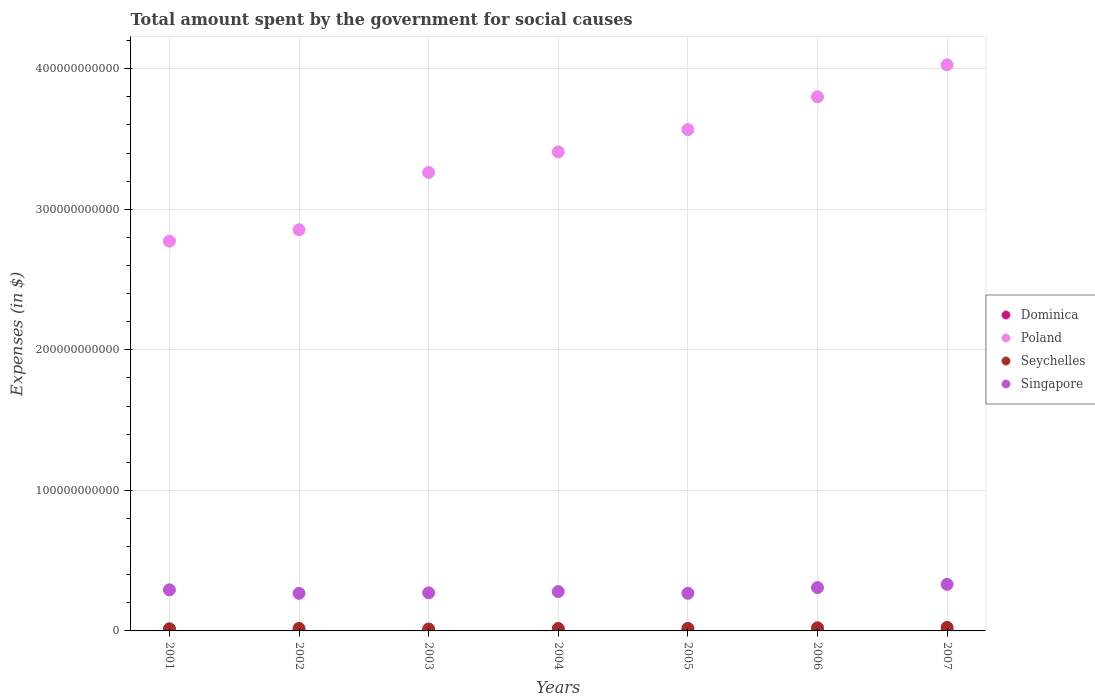How many different coloured dotlines are there?
Keep it short and to the point. 4. Is the number of dotlines equal to the number of legend labels?
Offer a terse response. Yes. What is the amount spent for social causes by the government in Singapore in 2002?
Make the answer very short. 2.68e+1. Across all years, what is the maximum amount spent for social causes by the government in Dominica?
Your answer should be compact. 2.68e+08. Across all years, what is the minimum amount spent for social causes by the government in Dominica?
Offer a terse response. 2.31e+08. In which year was the amount spent for social causes by the government in Poland maximum?
Keep it short and to the point. 2007. What is the total amount spent for social causes by the government in Seychelles in the graph?
Offer a terse response. 1.30e+1. What is the difference between the amount spent for social causes by the government in Dominica in 2005 and that in 2006?
Give a very brief answer. -6.80e+06. What is the difference between the amount spent for social causes by the government in Dominica in 2004 and the amount spent for social causes by the government in Singapore in 2007?
Your answer should be compact. -3.29e+1. What is the average amount spent for social causes by the government in Poland per year?
Your answer should be very brief. 3.38e+11. In the year 2003, what is the difference between the amount spent for social causes by the government in Poland and amount spent for social causes by the government in Dominica?
Provide a short and direct response. 3.26e+11. In how many years, is the amount spent for social causes by the government in Singapore greater than 280000000000 $?
Your answer should be compact. 0. What is the ratio of the amount spent for social causes by the government in Singapore in 2002 to that in 2004?
Your answer should be compact. 0.96. Is the amount spent for social causes by the government in Dominica in 2001 less than that in 2007?
Provide a succinct answer. Yes. Is the difference between the amount spent for social causes by the government in Poland in 2001 and 2003 greater than the difference between the amount spent for social causes by the government in Dominica in 2001 and 2003?
Offer a very short reply. No. What is the difference between the highest and the second highest amount spent for social causes by the government in Poland?
Your answer should be very brief. 2.27e+1. What is the difference between the highest and the lowest amount spent for social causes by the government in Singapore?
Offer a very short reply. 6.38e+09. Is it the case that in every year, the sum of the amount spent for social causes by the government in Seychelles and amount spent for social causes by the government in Poland  is greater than the sum of amount spent for social causes by the government in Dominica and amount spent for social causes by the government in Singapore?
Give a very brief answer. Yes. Is it the case that in every year, the sum of the amount spent for social causes by the government in Seychelles and amount spent for social causes by the government in Dominica  is greater than the amount spent for social causes by the government in Singapore?
Your response must be concise. No. Does the amount spent for social causes by the government in Seychelles monotonically increase over the years?
Offer a terse response. No. Is the amount spent for social causes by the government in Singapore strictly less than the amount spent for social causes by the government in Seychelles over the years?
Give a very brief answer. No. What is the difference between two consecutive major ticks on the Y-axis?
Give a very brief answer. 1.00e+11. Are the values on the major ticks of Y-axis written in scientific E-notation?
Your answer should be very brief. No. Does the graph contain grids?
Provide a short and direct response. Yes. How many legend labels are there?
Your answer should be compact. 4. How are the legend labels stacked?
Provide a succinct answer. Vertical. What is the title of the graph?
Your response must be concise. Total amount spent by the government for social causes. Does "Indonesia" appear as one of the legend labels in the graph?
Offer a very short reply. No. What is the label or title of the Y-axis?
Give a very brief answer. Expenses (in $). What is the Expenses (in $) of Dominica in 2001?
Keep it short and to the point. 2.38e+08. What is the Expenses (in $) of Poland in 2001?
Give a very brief answer. 2.77e+11. What is the Expenses (in $) of Seychelles in 2001?
Make the answer very short. 1.53e+09. What is the Expenses (in $) of Singapore in 2001?
Your response must be concise. 2.92e+1. What is the Expenses (in $) in Dominica in 2002?
Your answer should be compact. 2.31e+08. What is the Expenses (in $) of Poland in 2002?
Provide a short and direct response. 2.85e+11. What is the Expenses (in $) in Seychelles in 2002?
Your answer should be compact. 1.81e+09. What is the Expenses (in $) of Singapore in 2002?
Provide a short and direct response. 2.68e+1. What is the Expenses (in $) of Dominica in 2003?
Offer a terse response. 2.32e+08. What is the Expenses (in $) in Poland in 2003?
Give a very brief answer. 3.26e+11. What is the Expenses (in $) of Seychelles in 2003?
Your answer should be very brief. 1.37e+09. What is the Expenses (in $) of Singapore in 2003?
Your answer should be compact. 2.71e+1. What is the Expenses (in $) of Dominica in 2004?
Provide a short and direct response. 2.33e+08. What is the Expenses (in $) in Poland in 2004?
Offer a terse response. 3.41e+11. What is the Expenses (in $) in Seychelles in 2004?
Keep it short and to the point. 1.74e+09. What is the Expenses (in $) in Singapore in 2004?
Ensure brevity in your answer.  2.80e+1. What is the Expenses (in $) in Dominica in 2005?
Provide a succinct answer. 2.37e+08. What is the Expenses (in $) of Poland in 2005?
Ensure brevity in your answer.  3.57e+11. What is the Expenses (in $) of Seychelles in 2005?
Provide a short and direct response. 1.83e+09. What is the Expenses (in $) of Singapore in 2005?
Make the answer very short. 2.68e+1. What is the Expenses (in $) of Dominica in 2006?
Offer a terse response. 2.44e+08. What is the Expenses (in $) of Poland in 2006?
Offer a terse response. 3.80e+11. What is the Expenses (in $) of Seychelles in 2006?
Ensure brevity in your answer.  2.22e+09. What is the Expenses (in $) in Singapore in 2006?
Your answer should be compact. 3.08e+1. What is the Expenses (in $) of Dominica in 2007?
Ensure brevity in your answer.  2.68e+08. What is the Expenses (in $) in Poland in 2007?
Provide a succinct answer. 4.03e+11. What is the Expenses (in $) of Seychelles in 2007?
Keep it short and to the point. 2.52e+09. What is the Expenses (in $) of Singapore in 2007?
Offer a terse response. 3.31e+1. Across all years, what is the maximum Expenses (in $) in Dominica?
Keep it short and to the point. 2.68e+08. Across all years, what is the maximum Expenses (in $) of Poland?
Ensure brevity in your answer.  4.03e+11. Across all years, what is the maximum Expenses (in $) in Seychelles?
Offer a very short reply. 2.52e+09. Across all years, what is the maximum Expenses (in $) of Singapore?
Your response must be concise. 3.31e+1. Across all years, what is the minimum Expenses (in $) in Dominica?
Your answer should be very brief. 2.31e+08. Across all years, what is the minimum Expenses (in $) of Poland?
Provide a succinct answer. 2.77e+11. Across all years, what is the minimum Expenses (in $) of Seychelles?
Offer a terse response. 1.37e+09. Across all years, what is the minimum Expenses (in $) of Singapore?
Your answer should be compact. 2.68e+1. What is the total Expenses (in $) in Dominica in the graph?
Ensure brevity in your answer.  1.68e+09. What is the total Expenses (in $) in Poland in the graph?
Offer a very short reply. 2.37e+12. What is the total Expenses (in $) in Seychelles in the graph?
Your response must be concise. 1.30e+1. What is the total Expenses (in $) in Singapore in the graph?
Make the answer very short. 2.02e+11. What is the difference between the Expenses (in $) in Dominica in 2001 and that in 2002?
Your answer should be compact. 7.60e+06. What is the difference between the Expenses (in $) of Poland in 2001 and that in 2002?
Offer a very short reply. -8.10e+09. What is the difference between the Expenses (in $) of Seychelles in 2001 and that in 2002?
Provide a succinct answer. -2.84e+08. What is the difference between the Expenses (in $) of Singapore in 2001 and that in 2002?
Provide a succinct answer. 2.48e+09. What is the difference between the Expenses (in $) of Dominica in 2001 and that in 2003?
Offer a very short reply. 6.70e+06. What is the difference between the Expenses (in $) in Poland in 2001 and that in 2003?
Ensure brevity in your answer.  -4.89e+1. What is the difference between the Expenses (in $) in Seychelles in 2001 and that in 2003?
Offer a very short reply. 1.54e+08. What is the difference between the Expenses (in $) in Singapore in 2001 and that in 2003?
Your answer should be very brief. 2.12e+09. What is the difference between the Expenses (in $) of Dominica in 2001 and that in 2004?
Your answer should be very brief. 5.10e+06. What is the difference between the Expenses (in $) of Poland in 2001 and that in 2004?
Make the answer very short. -6.35e+1. What is the difference between the Expenses (in $) of Seychelles in 2001 and that in 2004?
Keep it short and to the point. -2.11e+08. What is the difference between the Expenses (in $) in Singapore in 2001 and that in 2004?
Keep it short and to the point. 1.25e+09. What is the difference between the Expenses (in $) in Dominica in 2001 and that in 2005?
Your answer should be very brief. 8.00e+05. What is the difference between the Expenses (in $) of Poland in 2001 and that in 2005?
Make the answer very short. -7.93e+1. What is the difference between the Expenses (in $) of Seychelles in 2001 and that in 2005?
Keep it short and to the point. -3.07e+08. What is the difference between the Expenses (in $) of Singapore in 2001 and that in 2005?
Offer a terse response. 2.44e+09. What is the difference between the Expenses (in $) of Dominica in 2001 and that in 2006?
Your answer should be compact. -6.00e+06. What is the difference between the Expenses (in $) in Poland in 2001 and that in 2006?
Give a very brief answer. -1.03e+11. What is the difference between the Expenses (in $) in Seychelles in 2001 and that in 2006?
Ensure brevity in your answer.  -6.97e+08. What is the difference between the Expenses (in $) of Singapore in 2001 and that in 2006?
Provide a succinct answer. -1.60e+09. What is the difference between the Expenses (in $) in Dominica in 2001 and that in 2007?
Ensure brevity in your answer.  -2.97e+07. What is the difference between the Expenses (in $) of Poland in 2001 and that in 2007?
Ensure brevity in your answer.  -1.25e+11. What is the difference between the Expenses (in $) of Seychelles in 2001 and that in 2007?
Your response must be concise. -9.91e+08. What is the difference between the Expenses (in $) in Singapore in 2001 and that in 2007?
Your answer should be very brief. -3.90e+09. What is the difference between the Expenses (in $) of Dominica in 2002 and that in 2003?
Keep it short and to the point. -9.00e+05. What is the difference between the Expenses (in $) of Poland in 2002 and that in 2003?
Provide a short and direct response. -4.08e+1. What is the difference between the Expenses (in $) in Seychelles in 2002 and that in 2003?
Offer a very short reply. 4.38e+08. What is the difference between the Expenses (in $) of Singapore in 2002 and that in 2003?
Your answer should be very brief. -3.59e+08. What is the difference between the Expenses (in $) of Dominica in 2002 and that in 2004?
Give a very brief answer. -2.50e+06. What is the difference between the Expenses (in $) of Poland in 2002 and that in 2004?
Provide a succinct answer. -5.54e+1. What is the difference between the Expenses (in $) in Seychelles in 2002 and that in 2004?
Give a very brief answer. 7.30e+07. What is the difference between the Expenses (in $) of Singapore in 2002 and that in 2004?
Ensure brevity in your answer.  -1.23e+09. What is the difference between the Expenses (in $) of Dominica in 2002 and that in 2005?
Ensure brevity in your answer.  -6.80e+06. What is the difference between the Expenses (in $) of Poland in 2002 and that in 2005?
Offer a very short reply. -7.12e+1. What is the difference between the Expenses (in $) of Seychelles in 2002 and that in 2005?
Your answer should be compact. -2.29e+07. What is the difference between the Expenses (in $) of Singapore in 2002 and that in 2005?
Give a very brief answer. -3.70e+07. What is the difference between the Expenses (in $) of Dominica in 2002 and that in 2006?
Offer a very short reply. -1.36e+07. What is the difference between the Expenses (in $) in Poland in 2002 and that in 2006?
Your response must be concise. -9.46e+1. What is the difference between the Expenses (in $) in Seychelles in 2002 and that in 2006?
Your answer should be compact. -4.14e+08. What is the difference between the Expenses (in $) in Singapore in 2002 and that in 2006?
Offer a terse response. -4.08e+09. What is the difference between the Expenses (in $) of Dominica in 2002 and that in 2007?
Provide a succinct answer. -3.73e+07. What is the difference between the Expenses (in $) in Poland in 2002 and that in 2007?
Offer a very short reply. -1.17e+11. What is the difference between the Expenses (in $) in Seychelles in 2002 and that in 2007?
Provide a succinct answer. -7.07e+08. What is the difference between the Expenses (in $) in Singapore in 2002 and that in 2007?
Offer a very short reply. -6.38e+09. What is the difference between the Expenses (in $) in Dominica in 2003 and that in 2004?
Provide a short and direct response. -1.60e+06. What is the difference between the Expenses (in $) of Poland in 2003 and that in 2004?
Provide a succinct answer. -1.47e+1. What is the difference between the Expenses (in $) of Seychelles in 2003 and that in 2004?
Provide a short and direct response. -3.65e+08. What is the difference between the Expenses (in $) in Singapore in 2003 and that in 2004?
Offer a terse response. -8.71e+08. What is the difference between the Expenses (in $) of Dominica in 2003 and that in 2005?
Your response must be concise. -5.90e+06. What is the difference between the Expenses (in $) in Poland in 2003 and that in 2005?
Make the answer very short. -3.05e+1. What is the difference between the Expenses (in $) of Seychelles in 2003 and that in 2005?
Your response must be concise. -4.61e+08. What is the difference between the Expenses (in $) of Singapore in 2003 and that in 2005?
Provide a succinct answer. 3.22e+08. What is the difference between the Expenses (in $) of Dominica in 2003 and that in 2006?
Offer a terse response. -1.27e+07. What is the difference between the Expenses (in $) of Poland in 2003 and that in 2006?
Offer a terse response. -5.39e+1. What is the difference between the Expenses (in $) of Seychelles in 2003 and that in 2006?
Your answer should be compact. -8.52e+08. What is the difference between the Expenses (in $) of Singapore in 2003 and that in 2006?
Your answer should be compact. -3.72e+09. What is the difference between the Expenses (in $) of Dominica in 2003 and that in 2007?
Your response must be concise. -3.64e+07. What is the difference between the Expenses (in $) of Poland in 2003 and that in 2007?
Offer a terse response. -7.66e+1. What is the difference between the Expenses (in $) in Seychelles in 2003 and that in 2007?
Provide a short and direct response. -1.15e+09. What is the difference between the Expenses (in $) of Singapore in 2003 and that in 2007?
Offer a terse response. -6.02e+09. What is the difference between the Expenses (in $) of Dominica in 2004 and that in 2005?
Give a very brief answer. -4.30e+06. What is the difference between the Expenses (in $) in Poland in 2004 and that in 2005?
Your answer should be very brief. -1.58e+1. What is the difference between the Expenses (in $) of Seychelles in 2004 and that in 2005?
Provide a short and direct response. -9.59e+07. What is the difference between the Expenses (in $) of Singapore in 2004 and that in 2005?
Keep it short and to the point. 1.19e+09. What is the difference between the Expenses (in $) of Dominica in 2004 and that in 2006?
Make the answer very short. -1.11e+07. What is the difference between the Expenses (in $) in Poland in 2004 and that in 2006?
Your answer should be compact. -3.92e+1. What is the difference between the Expenses (in $) of Seychelles in 2004 and that in 2006?
Give a very brief answer. -4.87e+08. What is the difference between the Expenses (in $) in Singapore in 2004 and that in 2006?
Ensure brevity in your answer.  -2.85e+09. What is the difference between the Expenses (in $) of Dominica in 2004 and that in 2007?
Ensure brevity in your answer.  -3.48e+07. What is the difference between the Expenses (in $) in Poland in 2004 and that in 2007?
Ensure brevity in your answer.  -6.19e+1. What is the difference between the Expenses (in $) in Seychelles in 2004 and that in 2007?
Provide a succinct answer. -7.80e+08. What is the difference between the Expenses (in $) in Singapore in 2004 and that in 2007?
Offer a very short reply. -5.15e+09. What is the difference between the Expenses (in $) of Dominica in 2005 and that in 2006?
Ensure brevity in your answer.  -6.80e+06. What is the difference between the Expenses (in $) of Poland in 2005 and that in 2006?
Your response must be concise. -2.34e+1. What is the difference between the Expenses (in $) in Seychelles in 2005 and that in 2006?
Your answer should be very brief. -3.91e+08. What is the difference between the Expenses (in $) of Singapore in 2005 and that in 2006?
Offer a very short reply. -4.04e+09. What is the difference between the Expenses (in $) in Dominica in 2005 and that in 2007?
Ensure brevity in your answer.  -3.05e+07. What is the difference between the Expenses (in $) in Poland in 2005 and that in 2007?
Your answer should be compact. -4.61e+1. What is the difference between the Expenses (in $) of Seychelles in 2005 and that in 2007?
Keep it short and to the point. -6.84e+08. What is the difference between the Expenses (in $) in Singapore in 2005 and that in 2007?
Make the answer very short. -6.34e+09. What is the difference between the Expenses (in $) in Dominica in 2006 and that in 2007?
Keep it short and to the point. -2.37e+07. What is the difference between the Expenses (in $) in Poland in 2006 and that in 2007?
Provide a short and direct response. -2.27e+1. What is the difference between the Expenses (in $) of Seychelles in 2006 and that in 2007?
Provide a succinct answer. -2.94e+08. What is the difference between the Expenses (in $) in Singapore in 2006 and that in 2007?
Ensure brevity in your answer.  -2.30e+09. What is the difference between the Expenses (in $) in Dominica in 2001 and the Expenses (in $) in Poland in 2002?
Make the answer very short. -2.85e+11. What is the difference between the Expenses (in $) of Dominica in 2001 and the Expenses (in $) of Seychelles in 2002?
Your response must be concise. -1.57e+09. What is the difference between the Expenses (in $) in Dominica in 2001 and the Expenses (in $) in Singapore in 2002?
Ensure brevity in your answer.  -2.65e+1. What is the difference between the Expenses (in $) in Poland in 2001 and the Expenses (in $) in Seychelles in 2002?
Your response must be concise. 2.76e+11. What is the difference between the Expenses (in $) of Poland in 2001 and the Expenses (in $) of Singapore in 2002?
Provide a short and direct response. 2.51e+11. What is the difference between the Expenses (in $) of Seychelles in 2001 and the Expenses (in $) of Singapore in 2002?
Provide a succinct answer. -2.52e+1. What is the difference between the Expenses (in $) of Dominica in 2001 and the Expenses (in $) of Poland in 2003?
Provide a short and direct response. -3.26e+11. What is the difference between the Expenses (in $) of Dominica in 2001 and the Expenses (in $) of Seychelles in 2003?
Make the answer very short. -1.13e+09. What is the difference between the Expenses (in $) in Dominica in 2001 and the Expenses (in $) in Singapore in 2003?
Provide a succinct answer. -2.69e+1. What is the difference between the Expenses (in $) in Poland in 2001 and the Expenses (in $) in Seychelles in 2003?
Give a very brief answer. 2.76e+11. What is the difference between the Expenses (in $) in Poland in 2001 and the Expenses (in $) in Singapore in 2003?
Your answer should be very brief. 2.50e+11. What is the difference between the Expenses (in $) of Seychelles in 2001 and the Expenses (in $) of Singapore in 2003?
Keep it short and to the point. -2.56e+1. What is the difference between the Expenses (in $) of Dominica in 2001 and the Expenses (in $) of Poland in 2004?
Provide a succinct answer. -3.41e+11. What is the difference between the Expenses (in $) of Dominica in 2001 and the Expenses (in $) of Seychelles in 2004?
Your answer should be very brief. -1.50e+09. What is the difference between the Expenses (in $) of Dominica in 2001 and the Expenses (in $) of Singapore in 2004?
Offer a terse response. -2.77e+1. What is the difference between the Expenses (in $) of Poland in 2001 and the Expenses (in $) of Seychelles in 2004?
Your answer should be very brief. 2.76e+11. What is the difference between the Expenses (in $) of Poland in 2001 and the Expenses (in $) of Singapore in 2004?
Your response must be concise. 2.49e+11. What is the difference between the Expenses (in $) in Seychelles in 2001 and the Expenses (in $) in Singapore in 2004?
Your answer should be very brief. -2.65e+1. What is the difference between the Expenses (in $) in Dominica in 2001 and the Expenses (in $) in Poland in 2005?
Provide a succinct answer. -3.56e+11. What is the difference between the Expenses (in $) in Dominica in 2001 and the Expenses (in $) in Seychelles in 2005?
Offer a very short reply. -1.60e+09. What is the difference between the Expenses (in $) in Dominica in 2001 and the Expenses (in $) in Singapore in 2005?
Give a very brief answer. -2.66e+1. What is the difference between the Expenses (in $) of Poland in 2001 and the Expenses (in $) of Seychelles in 2005?
Your answer should be very brief. 2.76e+11. What is the difference between the Expenses (in $) in Poland in 2001 and the Expenses (in $) in Singapore in 2005?
Your answer should be compact. 2.51e+11. What is the difference between the Expenses (in $) in Seychelles in 2001 and the Expenses (in $) in Singapore in 2005?
Your answer should be compact. -2.53e+1. What is the difference between the Expenses (in $) in Dominica in 2001 and the Expenses (in $) in Poland in 2006?
Your answer should be very brief. -3.80e+11. What is the difference between the Expenses (in $) of Dominica in 2001 and the Expenses (in $) of Seychelles in 2006?
Your response must be concise. -1.99e+09. What is the difference between the Expenses (in $) in Dominica in 2001 and the Expenses (in $) in Singapore in 2006?
Make the answer very short. -3.06e+1. What is the difference between the Expenses (in $) in Poland in 2001 and the Expenses (in $) in Seychelles in 2006?
Your answer should be very brief. 2.75e+11. What is the difference between the Expenses (in $) in Poland in 2001 and the Expenses (in $) in Singapore in 2006?
Your response must be concise. 2.47e+11. What is the difference between the Expenses (in $) in Seychelles in 2001 and the Expenses (in $) in Singapore in 2006?
Offer a terse response. -2.93e+1. What is the difference between the Expenses (in $) in Dominica in 2001 and the Expenses (in $) in Poland in 2007?
Provide a succinct answer. -4.03e+11. What is the difference between the Expenses (in $) in Dominica in 2001 and the Expenses (in $) in Seychelles in 2007?
Give a very brief answer. -2.28e+09. What is the difference between the Expenses (in $) of Dominica in 2001 and the Expenses (in $) of Singapore in 2007?
Keep it short and to the point. -3.29e+1. What is the difference between the Expenses (in $) of Poland in 2001 and the Expenses (in $) of Seychelles in 2007?
Make the answer very short. 2.75e+11. What is the difference between the Expenses (in $) in Poland in 2001 and the Expenses (in $) in Singapore in 2007?
Offer a terse response. 2.44e+11. What is the difference between the Expenses (in $) in Seychelles in 2001 and the Expenses (in $) in Singapore in 2007?
Ensure brevity in your answer.  -3.16e+1. What is the difference between the Expenses (in $) in Dominica in 2002 and the Expenses (in $) in Poland in 2003?
Keep it short and to the point. -3.26e+11. What is the difference between the Expenses (in $) in Dominica in 2002 and the Expenses (in $) in Seychelles in 2003?
Ensure brevity in your answer.  -1.14e+09. What is the difference between the Expenses (in $) in Dominica in 2002 and the Expenses (in $) in Singapore in 2003?
Keep it short and to the point. -2.69e+1. What is the difference between the Expenses (in $) of Poland in 2002 and the Expenses (in $) of Seychelles in 2003?
Offer a very short reply. 2.84e+11. What is the difference between the Expenses (in $) in Poland in 2002 and the Expenses (in $) in Singapore in 2003?
Provide a short and direct response. 2.58e+11. What is the difference between the Expenses (in $) of Seychelles in 2002 and the Expenses (in $) of Singapore in 2003?
Provide a short and direct response. -2.53e+1. What is the difference between the Expenses (in $) in Dominica in 2002 and the Expenses (in $) in Poland in 2004?
Make the answer very short. -3.41e+11. What is the difference between the Expenses (in $) in Dominica in 2002 and the Expenses (in $) in Seychelles in 2004?
Keep it short and to the point. -1.51e+09. What is the difference between the Expenses (in $) of Dominica in 2002 and the Expenses (in $) of Singapore in 2004?
Keep it short and to the point. -2.78e+1. What is the difference between the Expenses (in $) of Poland in 2002 and the Expenses (in $) of Seychelles in 2004?
Your answer should be compact. 2.84e+11. What is the difference between the Expenses (in $) of Poland in 2002 and the Expenses (in $) of Singapore in 2004?
Your answer should be compact. 2.57e+11. What is the difference between the Expenses (in $) in Seychelles in 2002 and the Expenses (in $) in Singapore in 2004?
Give a very brief answer. -2.62e+1. What is the difference between the Expenses (in $) of Dominica in 2002 and the Expenses (in $) of Poland in 2005?
Make the answer very short. -3.56e+11. What is the difference between the Expenses (in $) of Dominica in 2002 and the Expenses (in $) of Seychelles in 2005?
Your answer should be compact. -1.60e+09. What is the difference between the Expenses (in $) in Dominica in 2002 and the Expenses (in $) in Singapore in 2005?
Give a very brief answer. -2.66e+1. What is the difference between the Expenses (in $) of Poland in 2002 and the Expenses (in $) of Seychelles in 2005?
Provide a short and direct response. 2.84e+11. What is the difference between the Expenses (in $) of Poland in 2002 and the Expenses (in $) of Singapore in 2005?
Offer a terse response. 2.59e+11. What is the difference between the Expenses (in $) of Seychelles in 2002 and the Expenses (in $) of Singapore in 2005?
Offer a terse response. -2.50e+1. What is the difference between the Expenses (in $) in Dominica in 2002 and the Expenses (in $) in Poland in 2006?
Offer a very short reply. -3.80e+11. What is the difference between the Expenses (in $) of Dominica in 2002 and the Expenses (in $) of Seychelles in 2006?
Offer a terse response. -1.99e+09. What is the difference between the Expenses (in $) in Dominica in 2002 and the Expenses (in $) in Singapore in 2006?
Offer a very short reply. -3.06e+1. What is the difference between the Expenses (in $) of Poland in 2002 and the Expenses (in $) of Seychelles in 2006?
Ensure brevity in your answer.  2.83e+11. What is the difference between the Expenses (in $) in Poland in 2002 and the Expenses (in $) in Singapore in 2006?
Your answer should be very brief. 2.55e+11. What is the difference between the Expenses (in $) of Seychelles in 2002 and the Expenses (in $) of Singapore in 2006?
Offer a terse response. -2.90e+1. What is the difference between the Expenses (in $) of Dominica in 2002 and the Expenses (in $) of Poland in 2007?
Your answer should be very brief. -4.03e+11. What is the difference between the Expenses (in $) in Dominica in 2002 and the Expenses (in $) in Seychelles in 2007?
Offer a very short reply. -2.29e+09. What is the difference between the Expenses (in $) in Dominica in 2002 and the Expenses (in $) in Singapore in 2007?
Your answer should be compact. -3.29e+1. What is the difference between the Expenses (in $) of Poland in 2002 and the Expenses (in $) of Seychelles in 2007?
Your response must be concise. 2.83e+11. What is the difference between the Expenses (in $) of Poland in 2002 and the Expenses (in $) of Singapore in 2007?
Ensure brevity in your answer.  2.52e+11. What is the difference between the Expenses (in $) of Seychelles in 2002 and the Expenses (in $) of Singapore in 2007?
Ensure brevity in your answer.  -3.13e+1. What is the difference between the Expenses (in $) in Dominica in 2003 and the Expenses (in $) in Poland in 2004?
Your answer should be very brief. -3.41e+11. What is the difference between the Expenses (in $) in Dominica in 2003 and the Expenses (in $) in Seychelles in 2004?
Provide a short and direct response. -1.51e+09. What is the difference between the Expenses (in $) in Dominica in 2003 and the Expenses (in $) in Singapore in 2004?
Your answer should be compact. -2.78e+1. What is the difference between the Expenses (in $) in Poland in 2003 and the Expenses (in $) in Seychelles in 2004?
Make the answer very short. 3.24e+11. What is the difference between the Expenses (in $) of Poland in 2003 and the Expenses (in $) of Singapore in 2004?
Provide a succinct answer. 2.98e+11. What is the difference between the Expenses (in $) in Seychelles in 2003 and the Expenses (in $) in Singapore in 2004?
Your answer should be compact. -2.66e+1. What is the difference between the Expenses (in $) in Dominica in 2003 and the Expenses (in $) in Poland in 2005?
Offer a terse response. -3.56e+11. What is the difference between the Expenses (in $) of Dominica in 2003 and the Expenses (in $) of Seychelles in 2005?
Offer a terse response. -1.60e+09. What is the difference between the Expenses (in $) of Dominica in 2003 and the Expenses (in $) of Singapore in 2005?
Keep it short and to the point. -2.66e+1. What is the difference between the Expenses (in $) in Poland in 2003 and the Expenses (in $) in Seychelles in 2005?
Offer a very short reply. 3.24e+11. What is the difference between the Expenses (in $) in Poland in 2003 and the Expenses (in $) in Singapore in 2005?
Make the answer very short. 2.99e+11. What is the difference between the Expenses (in $) in Seychelles in 2003 and the Expenses (in $) in Singapore in 2005?
Provide a succinct answer. -2.54e+1. What is the difference between the Expenses (in $) of Dominica in 2003 and the Expenses (in $) of Poland in 2006?
Your answer should be very brief. -3.80e+11. What is the difference between the Expenses (in $) in Dominica in 2003 and the Expenses (in $) in Seychelles in 2006?
Offer a very short reply. -1.99e+09. What is the difference between the Expenses (in $) of Dominica in 2003 and the Expenses (in $) of Singapore in 2006?
Ensure brevity in your answer.  -3.06e+1. What is the difference between the Expenses (in $) of Poland in 2003 and the Expenses (in $) of Seychelles in 2006?
Ensure brevity in your answer.  3.24e+11. What is the difference between the Expenses (in $) of Poland in 2003 and the Expenses (in $) of Singapore in 2006?
Ensure brevity in your answer.  2.95e+11. What is the difference between the Expenses (in $) of Seychelles in 2003 and the Expenses (in $) of Singapore in 2006?
Your response must be concise. -2.95e+1. What is the difference between the Expenses (in $) of Dominica in 2003 and the Expenses (in $) of Poland in 2007?
Provide a succinct answer. -4.03e+11. What is the difference between the Expenses (in $) of Dominica in 2003 and the Expenses (in $) of Seychelles in 2007?
Your answer should be very brief. -2.29e+09. What is the difference between the Expenses (in $) of Dominica in 2003 and the Expenses (in $) of Singapore in 2007?
Offer a very short reply. -3.29e+1. What is the difference between the Expenses (in $) in Poland in 2003 and the Expenses (in $) in Seychelles in 2007?
Offer a terse response. 3.24e+11. What is the difference between the Expenses (in $) in Poland in 2003 and the Expenses (in $) in Singapore in 2007?
Your answer should be very brief. 2.93e+11. What is the difference between the Expenses (in $) in Seychelles in 2003 and the Expenses (in $) in Singapore in 2007?
Keep it short and to the point. -3.18e+1. What is the difference between the Expenses (in $) in Dominica in 2004 and the Expenses (in $) in Poland in 2005?
Offer a terse response. -3.56e+11. What is the difference between the Expenses (in $) in Dominica in 2004 and the Expenses (in $) in Seychelles in 2005?
Your answer should be compact. -1.60e+09. What is the difference between the Expenses (in $) of Dominica in 2004 and the Expenses (in $) of Singapore in 2005?
Offer a terse response. -2.66e+1. What is the difference between the Expenses (in $) of Poland in 2004 and the Expenses (in $) of Seychelles in 2005?
Offer a terse response. 3.39e+11. What is the difference between the Expenses (in $) of Poland in 2004 and the Expenses (in $) of Singapore in 2005?
Your answer should be compact. 3.14e+11. What is the difference between the Expenses (in $) in Seychelles in 2004 and the Expenses (in $) in Singapore in 2005?
Give a very brief answer. -2.51e+1. What is the difference between the Expenses (in $) of Dominica in 2004 and the Expenses (in $) of Poland in 2006?
Your answer should be very brief. -3.80e+11. What is the difference between the Expenses (in $) of Dominica in 2004 and the Expenses (in $) of Seychelles in 2006?
Your answer should be compact. -1.99e+09. What is the difference between the Expenses (in $) in Dominica in 2004 and the Expenses (in $) in Singapore in 2006?
Offer a terse response. -3.06e+1. What is the difference between the Expenses (in $) of Poland in 2004 and the Expenses (in $) of Seychelles in 2006?
Offer a very short reply. 3.39e+11. What is the difference between the Expenses (in $) in Poland in 2004 and the Expenses (in $) in Singapore in 2006?
Give a very brief answer. 3.10e+11. What is the difference between the Expenses (in $) in Seychelles in 2004 and the Expenses (in $) in Singapore in 2006?
Offer a very short reply. -2.91e+1. What is the difference between the Expenses (in $) of Dominica in 2004 and the Expenses (in $) of Poland in 2007?
Your response must be concise. -4.03e+11. What is the difference between the Expenses (in $) in Dominica in 2004 and the Expenses (in $) in Seychelles in 2007?
Your response must be concise. -2.28e+09. What is the difference between the Expenses (in $) of Dominica in 2004 and the Expenses (in $) of Singapore in 2007?
Your answer should be very brief. -3.29e+1. What is the difference between the Expenses (in $) in Poland in 2004 and the Expenses (in $) in Seychelles in 2007?
Keep it short and to the point. 3.38e+11. What is the difference between the Expenses (in $) in Poland in 2004 and the Expenses (in $) in Singapore in 2007?
Give a very brief answer. 3.08e+11. What is the difference between the Expenses (in $) of Seychelles in 2004 and the Expenses (in $) of Singapore in 2007?
Provide a succinct answer. -3.14e+1. What is the difference between the Expenses (in $) in Dominica in 2005 and the Expenses (in $) in Poland in 2006?
Your response must be concise. -3.80e+11. What is the difference between the Expenses (in $) of Dominica in 2005 and the Expenses (in $) of Seychelles in 2006?
Provide a short and direct response. -1.99e+09. What is the difference between the Expenses (in $) in Dominica in 2005 and the Expenses (in $) in Singapore in 2006?
Make the answer very short. -3.06e+1. What is the difference between the Expenses (in $) in Poland in 2005 and the Expenses (in $) in Seychelles in 2006?
Make the answer very short. 3.54e+11. What is the difference between the Expenses (in $) in Poland in 2005 and the Expenses (in $) in Singapore in 2006?
Provide a succinct answer. 3.26e+11. What is the difference between the Expenses (in $) in Seychelles in 2005 and the Expenses (in $) in Singapore in 2006?
Ensure brevity in your answer.  -2.90e+1. What is the difference between the Expenses (in $) in Dominica in 2005 and the Expenses (in $) in Poland in 2007?
Provide a succinct answer. -4.03e+11. What is the difference between the Expenses (in $) of Dominica in 2005 and the Expenses (in $) of Seychelles in 2007?
Ensure brevity in your answer.  -2.28e+09. What is the difference between the Expenses (in $) of Dominica in 2005 and the Expenses (in $) of Singapore in 2007?
Your answer should be very brief. -3.29e+1. What is the difference between the Expenses (in $) of Poland in 2005 and the Expenses (in $) of Seychelles in 2007?
Offer a very short reply. 3.54e+11. What is the difference between the Expenses (in $) in Poland in 2005 and the Expenses (in $) in Singapore in 2007?
Your answer should be very brief. 3.24e+11. What is the difference between the Expenses (in $) of Seychelles in 2005 and the Expenses (in $) of Singapore in 2007?
Make the answer very short. -3.13e+1. What is the difference between the Expenses (in $) of Dominica in 2006 and the Expenses (in $) of Poland in 2007?
Give a very brief answer. -4.03e+11. What is the difference between the Expenses (in $) of Dominica in 2006 and the Expenses (in $) of Seychelles in 2007?
Offer a very short reply. -2.27e+09. What is the difference between the Expenses (in $) of Dominica in 2006 and the Expenses (in $) of Singapore in 2007?
Provide a succinct answer. -3.29e+1. What is the difference between the Expenses (in $) of Poland in 2006 and the Expenses (in $) of Seychelles in 2007?
Your response must be concise. 3.78e+11. What is the difference between the Expenses (in $) in Poland in 2006 and the Expenses (in $) in Singapore in 2007?
Make the answer very short. 3.47e+11. What is the difference between the Expenses (in $) in Seychelles in 2006 and the Expenses (in $) in Singapore in 2007?
Your response must be concise. -3.09e+1. What is the average Expenses (in $) of Dominica per year?
Ensure brevity in your answer.  2.40e+08. What is the average Expenses (in $) in Poland per year?
Make the answer very short. 3.38e+11. What is the average Expenses (in $) in Seychelles per year?
Provide a succinct answer. 1.86e+09. What is the average Expenses (in $) of Singapore per year?
Your answer should be compact. 2.88e+1. In the year 2001, what is the difference between the Expenses (in $) in Dominica and Expenses (in $) in Poland?
Give a very brief answer. -2.77e+11. In the year 2001, what is the difference between the Expenses (in $) in Dominica and Expenses (in $) in Seychelles?
Ensure brevity in your answer.  -1.29e+09. In the year 2001, what is the difference between the Expenses (in $) in Dominica and Expenses (in $) in Singapore?
Provide a short and direct response. -2.90e+1. In the year 2001, what is the difference between the Expenses (in $) of Poland and Expenses (in $) of Seychelles?
Provide a succinct answer. 2.76e+11. In the year 2001, what is the difference between the Expenses (in $) of Poland and Expenses (in $) of Singapore?
Provide a succinct answer. 2.48e+11. In the year 2001, what is the difference between the Expenses (in $) in Seychelles and Expenses (in $) in Singapore?
Your answer should be compact. -2.77e+1. In the year 2002, what is the difference between the Expenses (in $) of Dominica and Expenses (in $) of Poland?
Make the answer very short. -2.85e+11. In the year 2002, what is the difference between the Expenses (in $) in Dominica and Expenses (in $) in Seychelles?
Provide a short and direct response. -1.58e+09. In the year 2002, what is the difference between the Expenses (in $) in Dominica and Expenses (in $) in Singapore?
Your answer should be very brief. -2.65e+1. In the year 2002, what is the difference between the Expenses (in $) of Poland and Expenses (in $) of Seychelles?
Provide a short and direct response. 2.84e+11. In the year 2002, what is the difference between the Expenses (in $) of Poland and Expenses (in $) of Singapore?
Your response must be concise. 2.59e+11. In the year 2002, what is the difference between the Expenses (in $) of Seychelles and Expenses (in $) of Singapore?
Make the answer very short. -2.49e+1. In the year 2003, what is the difference between the Expenses (in $) in Dominica and Expenses (in $) in Poland?
Your answer should be compact. -3.26e+11. In the year 2003, what is the difference between the Expenses (in $) in Dominica and Expenses (in $) in Seychelles?
Provide a succinct answer. -1.14e+09. In the year 2003, what is the difference between the Expenses (in $) of Dominica and Expenses (in $) of Singapore?
Your answer should be very brief. -2.69e+1. In the year 2003, what is the difference between the Expenses (in $) in Poland and Expenses (in $) in Seychelles?
Keep it short and to the point. 3.25e+11. In the year 2003, what is the difference between the Expenses (in $) of Poland and Expenses (in $) of Singapore?
Offer a very short reply. 2.99e+11. In the year 2003, what is the difference between the Expenses (in $) in Seychelles and Expenses (in $) in Singapore?
Make the answer very short. -2.57e+1. In the year 2004, what is the difference between the Expenses (in $) in Dominica and Expenses (in $) in Poland?
Your response must be concise. -3.41e+11. In the year 2004, what is the difference between the Expenses (in $) of Dominica and Expenses (in $) of Seychelles?
Offer a very short reply. -1.50e+09. In the year 2004, what is the difference between the Expenses (in $) in Dominica and Expenses (in $) in Singapore?
Offer a very short reply. -2.77e+1. In the year 2004, what is the difference between the Expenses (in $) in Poland and Expenses (in $) in Seychelles?
Give a very brief answer. 3.39e+11. In the year 2004, what is the difference between the Expenses (in $) in Poland and Expenses (in $) in Singapore?
Your answer should be very brief. 3.13e+11. In the year 2004, what is the difference between the Expenses (in $) of Seychelles and Expenses (in $) of Singapore?
Provide a succinct answer. -2.62e+1. In the year 2005, what is the difference between the Expenses (in $) in Dominica and Expenses (in $) in Poland?
Give a very brief answer. -3.56e+11. In the year 2005, what is the difference between the Expenses (in $) in Dominica and Expenses (in $) in Seychelles?
Offer a very short reply. -1.60e+09. In the year 2005, what is the difference between the Expenses (in $) in Dominica and Expenses (in $) in Singapore?
Your answer should be compact. -2.66e+1. In the year 2005, what is the difference between the Expenses (in $) of Poland and Expenses (in $) of Seychelles?
Your answer should be compact. 3.55e+11. In the year 2005, what is the difference between the Expenses (in $) in Poland and Expenses (in $) in Singapore?
Offer a very short reply. 3.30e+11. In the year 2005, what is the difference between the Expenses (in $) of Seychelles and Expenses (in $) of Singapore?
Offer a very short reply. -2.50e+1. In the year 2006, what is the difference between the Expenses (in $) in Dominica and Expenses (in $) in Poland?
Your answer should be very brief. -3.80e+11. In the year 2006, what is the difference between the Expenses (in $) of Dominica and Expenses (in $) of Seychelles?
Offer a very short reply. -1.98e+09. In the year 2006, what is the difference between the Expenses (in $) in Dominica and Expenses (in $) in Singapore?
Provide a short and direct response. -3.06e+1. In the year 2006, what is the difference between the Expenses (in $) in Poland and Expenses (in $) in Seychelles?
Your response must be concise. 3.78e+11. In the year 2006, what is the difference between the Expenses (in $) in Poland and Expenses (in $) in Singapore?
Provide a succinct answer. 3.49e+11. In the year 2006, what is the difference between the Expenses (in $) in Seychelles and Expenses (in $) in Singapore?
Make the answer very short. -2.86e+1. In the year 2007, what is the difference between the Expenses (in $) in Dominica and Expenses (in $) in Poland?
Offer a terse response. -4.03e+11. In the year 2007, what is the difference between the Expenses (in $) in Dominica and Expenses (in $) in Seychelles?
Ensure brevity in your answer.  -2.25e+09. In the year 2007, what is the difference between the Expenses (in $) of Dominica and Expenses (in $) of Singapore?
Ensure brevity in your answer.  -3.29e+1. In the year 2007, what is the difference between the Expenses (in $) in Poland and Expenses (in $) in Seychelles?
Your answer should be very brief. 4.00e+11. In the year 2007, what is the difference between the Expenses (in $) in Poland and Expenses (in $) in Singapore?
Your answer should be compact. 3.70e+11. In the year 2007, what is the difference between the Expenses (in $) of Seychelles and Expenses (in $) of Singapore?
Ensure brevity in your answer.  -3.06e+1. What is the ratio of the Expenses (in $) in Dominica in 2001 to that in 2002?
Provide a succinct answer. 1.03. What is the ratio of the Expenses (in $) of Poland in 2001 to that in 2002?
Provide a short and direct response. 0.97. What is the ratio of the Expenses (in $) in Seychelles in 2001 to that in 2002?
Make the answer very short. 0.84. What is the ratio of the Expenses (in $) in Singapore in 2001 to that in 2002?
Your response must be concise. 1.09. What is the ratio of the Expenses (in $) of Dominica in 2001 to that in 2003?
Ensure brevity in your answer.  1.03. What is the ratio of the Expenses (in $) of Poland in 2001 to that in 2003?
Ensure brevity in your answer.  0.85. What is the ratio of the Expenses (in $) in Seychelles in 2001 to that in 2003?
Your answer should be compact. 1.11. What is the ratio of the Expenses (in $) in Singapore in 2001 to that in 2003?
Give a very brief answer. 1.08. What is the ratio of the Expenses (in $) of Dominica in 2001 to that in 2004?
Offer a terse response. 1.02. What is the ratio of the Expenses (in $) of Poland in 2001 to that in 2004?
Provide a succinct answer. 0.81. What is the ratio of the Expenses (in $) of Seychelles in 2001 to that in 2004?
Your response must be concise. 0.88. What is the ratio of the Expenses (in $) of Singapore in 2001 to that in 2004?
Keep it short and to the point. 1.04. What is the ratio of the Expenses (in $) of Poland in 2001 to that in 2005?
Give a very brief answer. 0.78. What is the ratio of the Expenses (in $) of Seychelles in 2001 to that in 2005?
Your response must be concise. 0.83. What is the ratio of the Expenses (in $) in Singapore in 2001 to that in 2005?
Keep it short and to the point. 1.09. What is the ratio of the Expenses (in $) in Dominica in 2001 to that in 2006?
Give a very brief answer. 0.98. What is the ratio of the Expenses (in $) in Poland in 2001 to that in 2006?
Offer a very short reply. 0.73. What is the ratio of the Expenses (in $) in Seychelles in 2001 to that in 2006?
Keep it short and to the point. 0.69. What is the ratio of the Expenses (in $) of Singapore in 2001 to that in 2006?
Provide a succinct answer. 0.95. What is the ratio of the Expenses (in $) of Dominica in 2001 to that in 2007?
Your answer should be very brief. 0.89. What is the ratio of the Expenses (in $) in Poland in 2001 to that in 2007?
Ensure brevity in your answer.  0.69. What is the ratio of the Expenses (in $) in Seychelles in 2001 to that in 2007?
Your response must be concise. 0.61. What is the ratio of the Expenses (in $) in Singapore in 2001 to that in 2007?
Make the answer very short. 0.88. What is the ratio of the Expenses (in $) in Poland in 2002 to that in 2003?
Offer a very short reply. 0.88. What is the ratio of the Expenses (in $) in Seychelles in 2002 to that in 2003?
Offer a terse response. 1.32. What is the ratio of the Expenses (in $) of Dominica in 2002 to that in 2004?
Provide a succinct answer. 0.99. What is the ratio of the Expenses (in $) of Poland in 2002 to that in 2004?
Offer a terse response. 0.84. What is the ratio of the Expenses (in $) of Seychelles in 2002 to that in 2004?
Make the answer very short. 1.04. What is the ratio of the Expenses (in $) of Singapore in 2002 to that in 2004?
Provide a short and direct response. 0.96. What is the ratio of the Expenses (in $) of Dominica in 2002 to that in 2005?
Keep it short and to the point. 0.97. What is the ratio of the Expenses (in $) in Poland in 2002 to that in 2005?
Your answer should be very brief. 0.8. What is the ratio of the Expenses (in $) in Seychelles in 2002 to that in 2005?
Keep it short and to the point. 0.99. What is the ratio of the Expenses (in $) in Singapore in 2002 to that in 2005?
Give a very brief answer. 1. What is the ratio of the Expenses (in $) of Dominica in 2002 to that in 2006?
Give a very brief answer. 0.94. What is the ratio of the Expenses (in $) of Poland in 2002 to that in 2006?
Offer a terse response. 0.75. What is the ratio of the Expenses (in $) in Seychelles in 2002 to that in 2006?
Your answer should be very brief. 0.81. What is the ratio of the Expenses (in $) of Singapore in 2002 to that in 2006?
Offer a very short reply. 0.87. What is the ratio of the Expenses (in $) of Dominica in 2002 to that in 2007?
Give a very brief answer. 0.86. What is the ratio of the Expenses (in $) in Poland in 2002 to that in 2007?
Your response must be concise. 0.71. What is the ratio of the Expenses (in $) in Seychelles in 2002 to that in 2007?
Ensure brevity in your answer.  0.72. What is the ratio of the Expenses (in $) in Singapore in 2002 to that in 2007?
Your answer should be compact. 0.81. What is the ratio of the Expenses (in $) in Poland in 2003 to that in 2004?
Provide a succinct answer. 0.96. What is the ratio of the Expenses (in $) of Seychelles in 2003 to that in 2004?
Provide a short and direct response. 0.79. What is the ratio of the Expenses (in $) in Singapore in 2003 to that in 2004?
Ensure brevity in your answer.  0.97. What is the ratio of the Expenses (in $) in Dominica in 2003 to that in 2005?
Offer a very short reply. 0.98. What is the ratio of the Expenses (in $) of Poland in 2003 to that in 2005?
Ensure brevity in your answer.  0.91. What is the ratio of the Expenses (in $) of Seychelles in 2003 to that in 2005?
Provide a succinct answer. 0.75. What is the ratio of the Expenses (in $) of Dominica in 2003 to that in 2006?
Make the answer very short. 0.95. What is the ratio of the Expenses (in $) of Poland in 2003 to that in 2006?
Make the answer very short. 0.86. What is the ratio of the Expenses (in $) of Seychelles in 2003 to that in 2006?
Give a very brief answer. 0.62. What is the ratio of the Expenses (in $) in Singapore in 2003 to that in 2006?
Your response must be concise. 0.88. What is the ratio of the Expenses (in $) of Dominica in 2003 to that in 2007?
Keep it short and to the point. 0.86. What is the ratio of the Expenses (in $) in Poland in 2003 to that in 2007?
Provide a succinct answer. 0.81. What is the ratio of the Expenses (in $) of Seychelles in 2003 to that in 2007?
Ensure brevity in your answer.  0.55. What is the ratio of the Expenses (in $) of Singapore in 2003 to that in 2007?
Your answer should be very brief. 0.82. What is the ratio of the Expenses (in $) in Dominica in 2004 to that in 2005?
Keep it short and to the point. 0.98. What is the ratio of the Expenses (in $) of Poland in 2004 to that in 2005?
Provide a succinct answer. 0.96. What is the ratio of the Expenses (in $) in Seychelles in 2004 to that in 2005?
Make the answer very short. 0.95. What is the ratio of the Expenses (in $) of Singapore in 2004 to that in 2005?
Give a very brief answer. 1.04. What is the ratio of the Expenses (in $) in Dominica in 2004 to that in 2006?
Your answer should be compact. 0.95. What is the ratio of the Expenses (in $) in Poland in 2004 to that in 2006?
Your answer should be compact. 0.9. What is the ratio of the Expenses (in $) of Seychelles in 2004 to that in 2006?
Keep it short and to the point. 0.78. What is the ratio of the Expenses (in $) in Singapore in 2004 to that in 2006?
Keep it short and to the point. 0.91. What is the ratio of the Expenses (in $) of Dominica in 2004 to that in 2007?
Keep it short and to the point. 0.87. What is the ratio of the Expenses (in $) of Poland in 2004 to that in 2007?
Provide a short and direct response. 0.85. What is the ratio of the Expenses (in $) of Seychelles in 2004 to that in 2007?
Your answer should be compact. 0.69. What is the ratio of the Expenses (in $) in Singapore in 2004 to that in 2007?
Provide a short and direct response. 0.84. What is the ratio of the Expenses (in $) in Dominica in 2005 to that in 2006?
Keep it short and to the point. 0.97. What is the ratio of the Expenses (in $) in Poland in 2005 to that in 2006?
Your answer should be compact. 0.94. What is the ratio of the Expenses (in $) of Seychelles in 2005 to that in 2006?
Your answer should be compact. 0.82. What is the ratio of the Expenses (in $) in Singapore in 2005 to that in 2006?
Keep it short and to the point. 0.87. What is the ratio of the Expenses (in $) in Dominica in 2005 to that in 2007?
Your answer should be very brief. 0.89. What is the ratio of the Expenses (in $) of Poland in 2005 to that in 2007?
Make the answer very short. 0.89. What is the ratio of the Expenses (in $) of Seychelles in 2005 to that in 2007?
Your answer should be compact. 0.73. What is the ratio of the Expenses (in $) of Singapore in 2005 to that in 2007?
Give a very brief answer. 0.81. What is the ratio of the Expenses (in $) of Dominica in 2006 to that in 2007?
Provide a short and direct response. 0.91. What is the ratio of the Expenses (in $) of Poland in 2006 to that in 2007?
Your answer should be compact. 0.94. What is the ratio of the Expenses (in $) in Seychelles in 2006 to that in 2007?
Make the answer very short. 0.88. What is the ratio of the Expenses (in $) of Singapore in 2006 to that in 2007?
Ensure brevity in your answer.  0.93. What is the difference between the highest and the second highest Expenses (in $) in Dominica?
Provide a short and direct response. 2.37e+07. What is the difference between the highest and the second highest Expenses (in $) in Poland?
Your response must be concise. 2.27e+1. What is the difference between the highest and the second highest Expenses (in $) of Seychelles?
Offer a very short reply. 2.94e+08. What is the difference between the highest and the second highest Expenses (in $) of Singapore?
Keep it short and to the point. 2.30e+09. What is the difference between the highest and the lowest Expenses (in $) of Dominica?
Provide a succinct answer. 3.73e+07. What is the difference between the highest and the lowest Expenses (in $) in Poland?
Offer a terse response. 1.25e+11. What is the difference between the highest and the lowest Expenses (in $) in Seychelles?
Offer a terse response. 1.15e+09. What is the difference between the highest and the lowest Expenses (in $) in Singapore?
Your answer should be compact. 6.38e+09. 